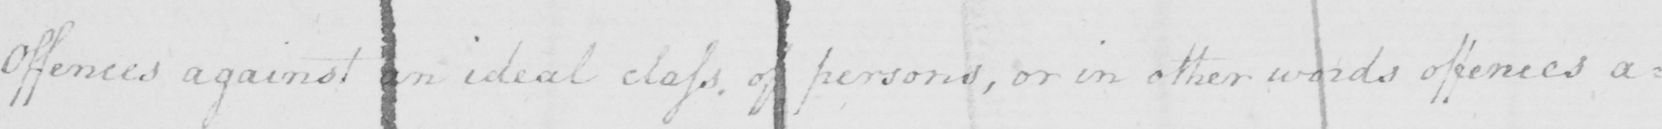Please transcribe the handwritten text in this image. Offences against an ideal class of persons , or in other words offences a= 